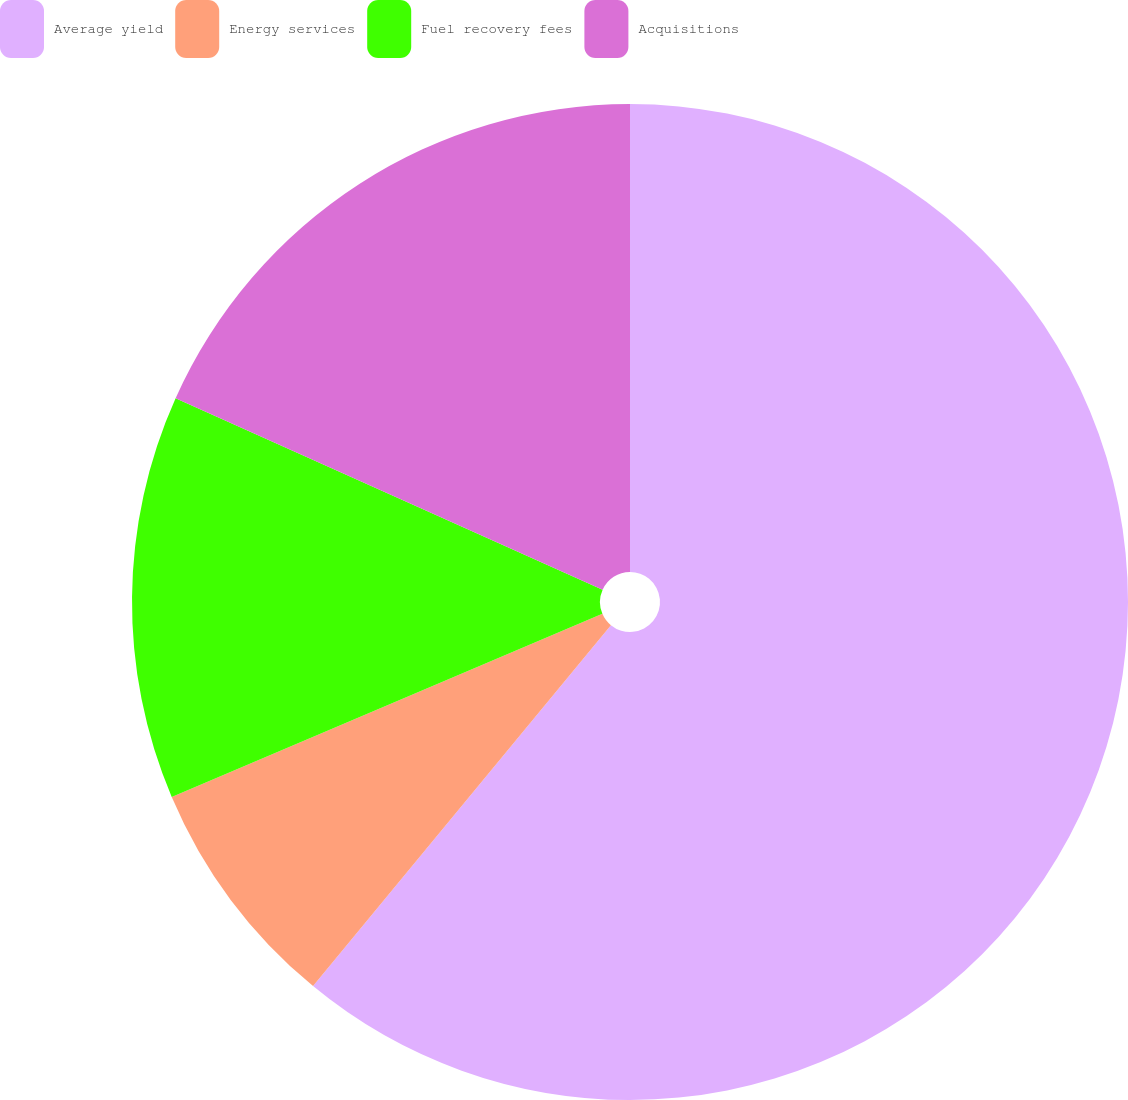Convert chart to OTSL. <chart><loc_0><loc_0><loc_500><loc_500><pie_chart><fcel>Average yield<fcel>Energy services<fcel>Fuel recovery fees<fcel>Acquisitions<nl><fcel>60.98%<fcel>7.62%<fcel>13.11%<fcel>18.29%<nl></chart> 